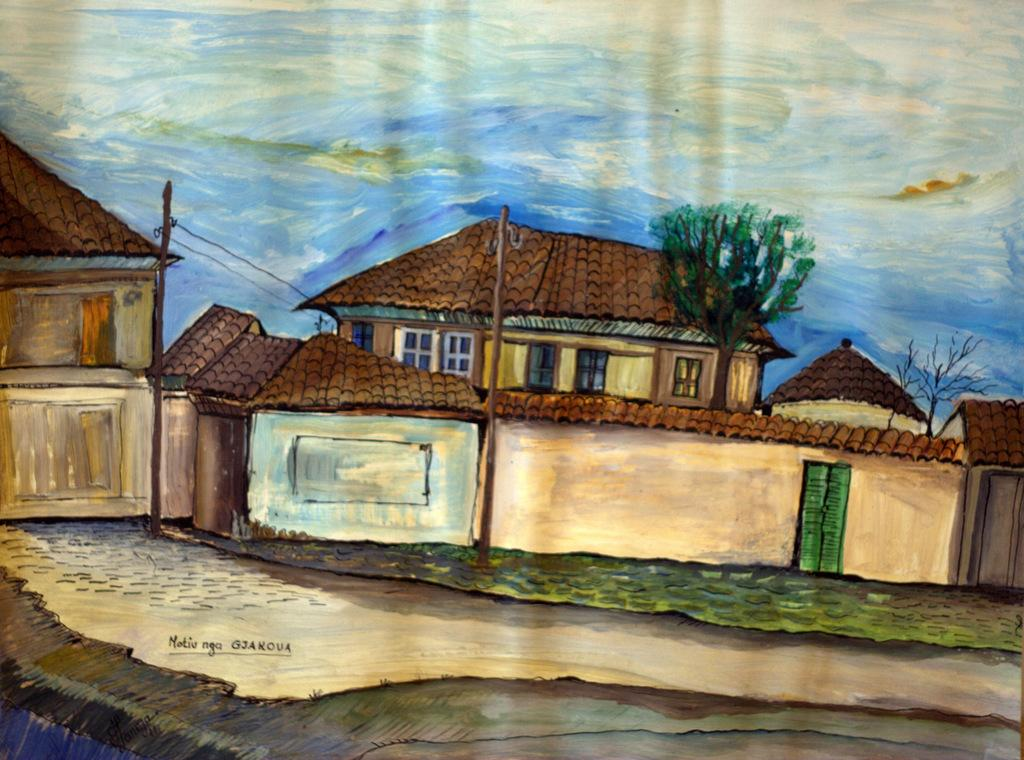What type of artwork is depicted in the image? The image is a painting. What structures can be seen in the painting? There are buildings in the painting. What other objects are present in the painting? There are poles, trees, and grass in the painting. What part of the natural environment is visible in the painting? The sky is visible in the painting. Is there any indication of who created the painting? Yes, there is a signature on the painting. What type of cushion is used to support the buildings in the painting? There is no cushion present in the painting; the buildings are standing on the ground. 